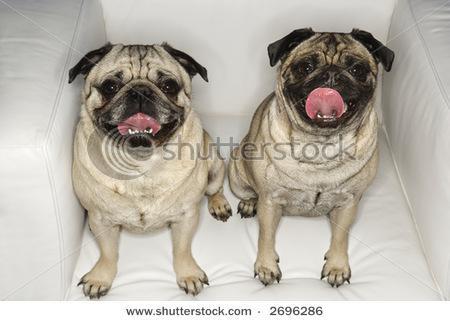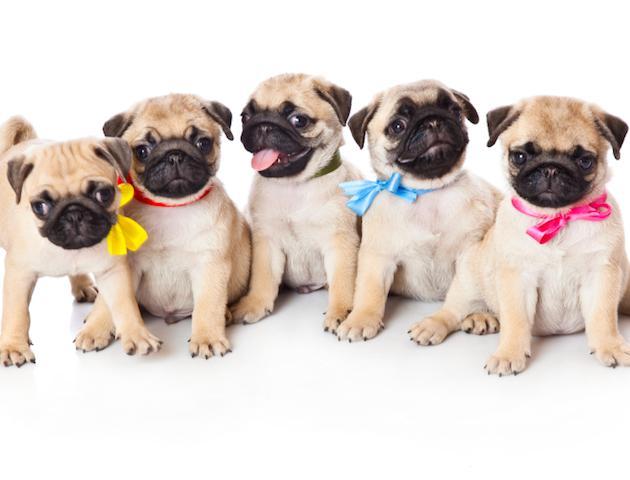The first image is the image on the left, the second image is the image on the right. Assess this claim about the two images: "The combined images include two dogs wearing Santa outfits, including red hats with white pom-poms.". Correct or not? Answer yes or no. No. The first image is the image on the left, the second image is the image on the right. For the images shown, is this caption "There are exactly four dogs in total." true? Answer yes or no. No. 